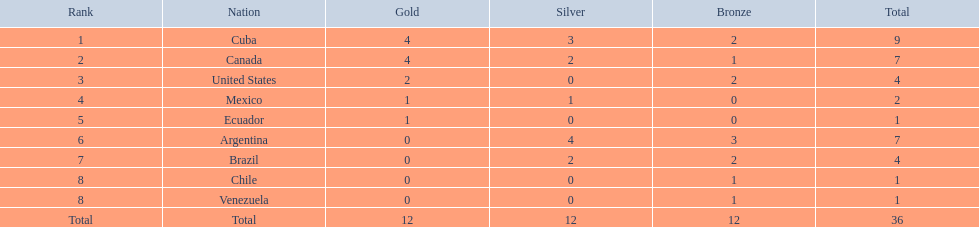Which nations competed in the 2011 pan american games? Cuba, Canada, United States, Mexico, Ecuador, Argentina, Brazil, Chile, Venezuela. Of these nations which ones won gold? Cuba, Canada, United States, Mexico, Ecuador. Which nation of the ones that won gold did not win silver? United States. 